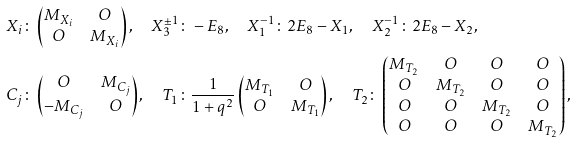Convert formula to latex. <formula><loc_0><loc_0><loc_500><loc_500>X _ { i } & \colon \begin{pmatrix} M _ { X _ { i } } & O \\ O & M _ { X _ { i } } \\ \end{pmatrix} , \quad X _ { 3 } ^ { \pm 1 } \colon - E _ { 8 } , \quad X _ { 1 } ^ { - 1 } \colon 2 E _ { 8 } - X _ { 1 } , \quad X _ { 2 } ^ { - 1 } \colon 2 E _ { 8 } - X _ { 2 } , \\ C _ { j } & \colon \begin{pmatrix} O & M _ { C _ { j } } \\ - M _ { C _ { j } } & O \\ \end{pmatrix} , \quad T _ { 1 } \colon \frac { 1 } { 1 + q ^ { 2 } } \begin{pmatrix} M _ { T _ { 1 } } & O \\ O & M _ { T _ { 1 } } \\ \end{pmatrix} , \quad T _ { 2 } \colon \begin{pmatrix} M _ { T _ { 2 } } & O & O & O \\ O & M _ { T _ { 2 } } & O & O \\ O & O & M _ { T _ { 2 } } & O \\ O & O & O & M _ { T _ { 2 } } \\ \end{pmatrix} ,</formula> 